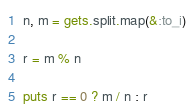<code> <loc_0><loc_0><loc_500><loc_500><_Ruby_>n, m = gets.split.map(&:to_i)

r = m % n

puts r == 0 ? m / n : r</code> 